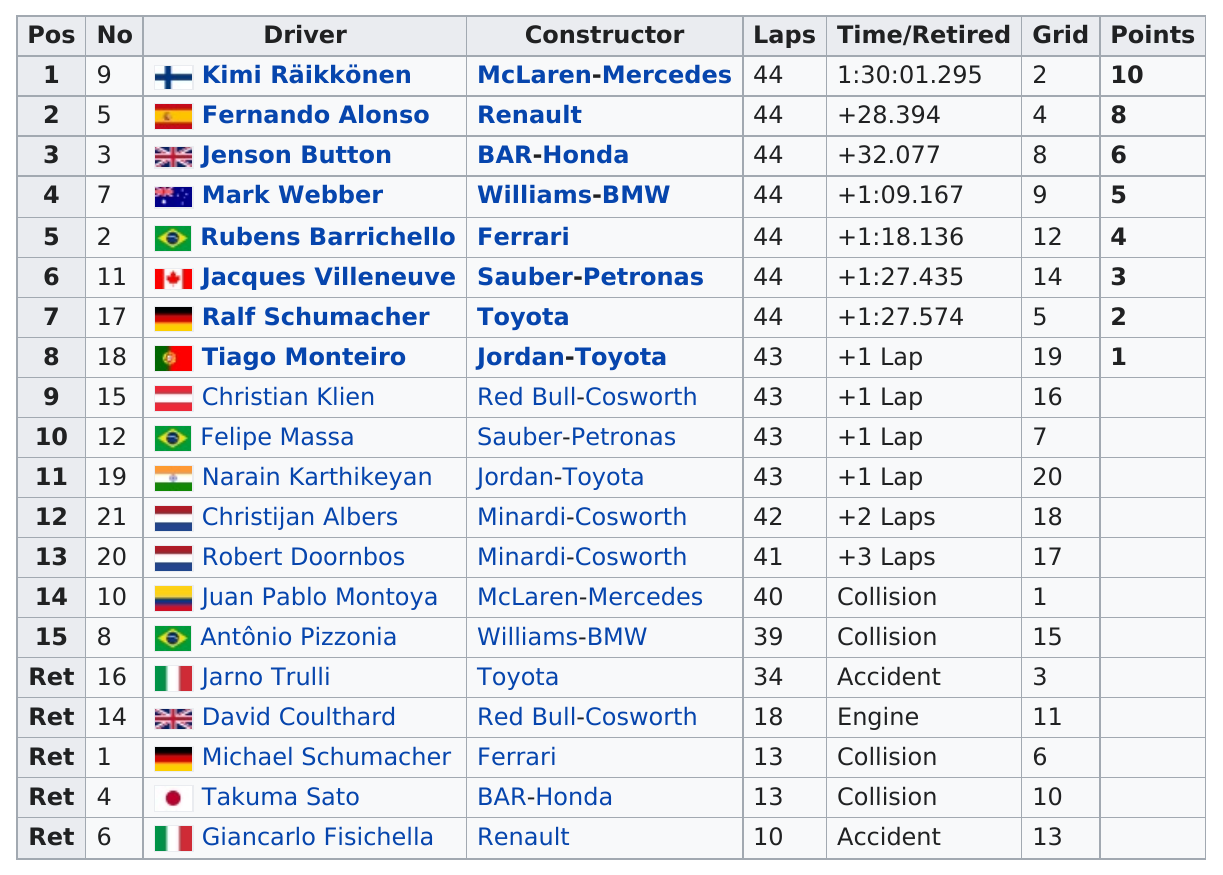Give some essential details in this illustration. At the 2005 Belgian Grand Prix, Kimi Räikkönen, Fernando Alonso, and Jenson Button were the top three finishers, marking a remarkable display of skill and determination. Juan Pablo Montoya completed 40 laps in the 2005 Belgian Grand Prix. In the 2005 Belgian Grand Prix, a total of five competitors did not finish the race. 